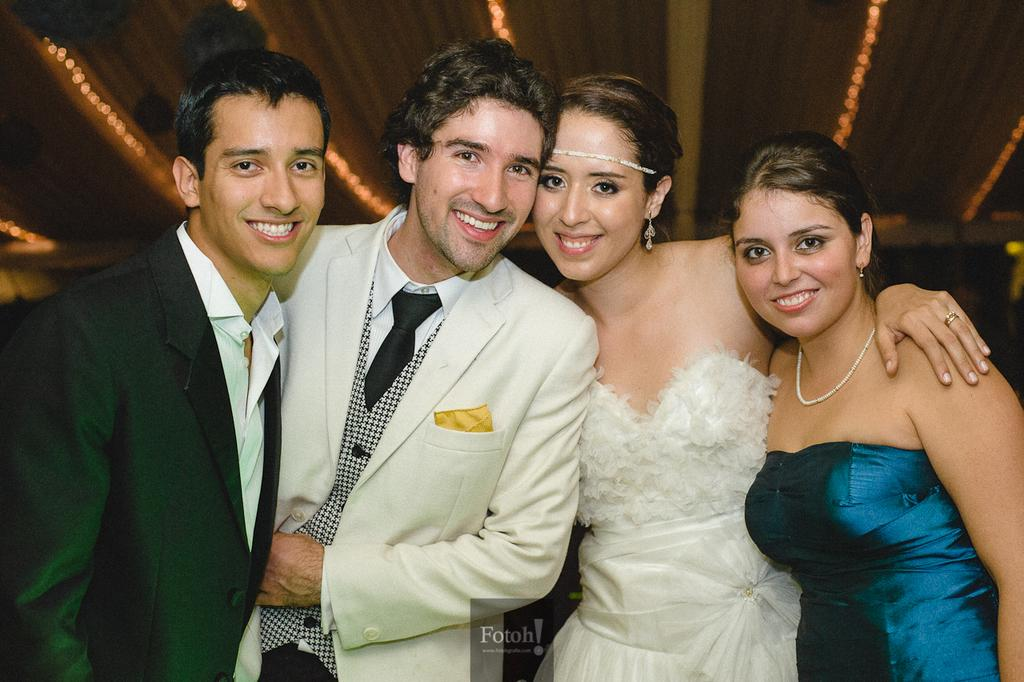What is located in the middle of the image? There are people standing in the middle of the image. What is the facial expression of the people in the image? The people are smiling. What can be seen in the background of the image? There is a wall in the background of the image. What type of island can be seen in the image? There is no island present in the image. What is the net used for in the image? There is no net present in the image. 